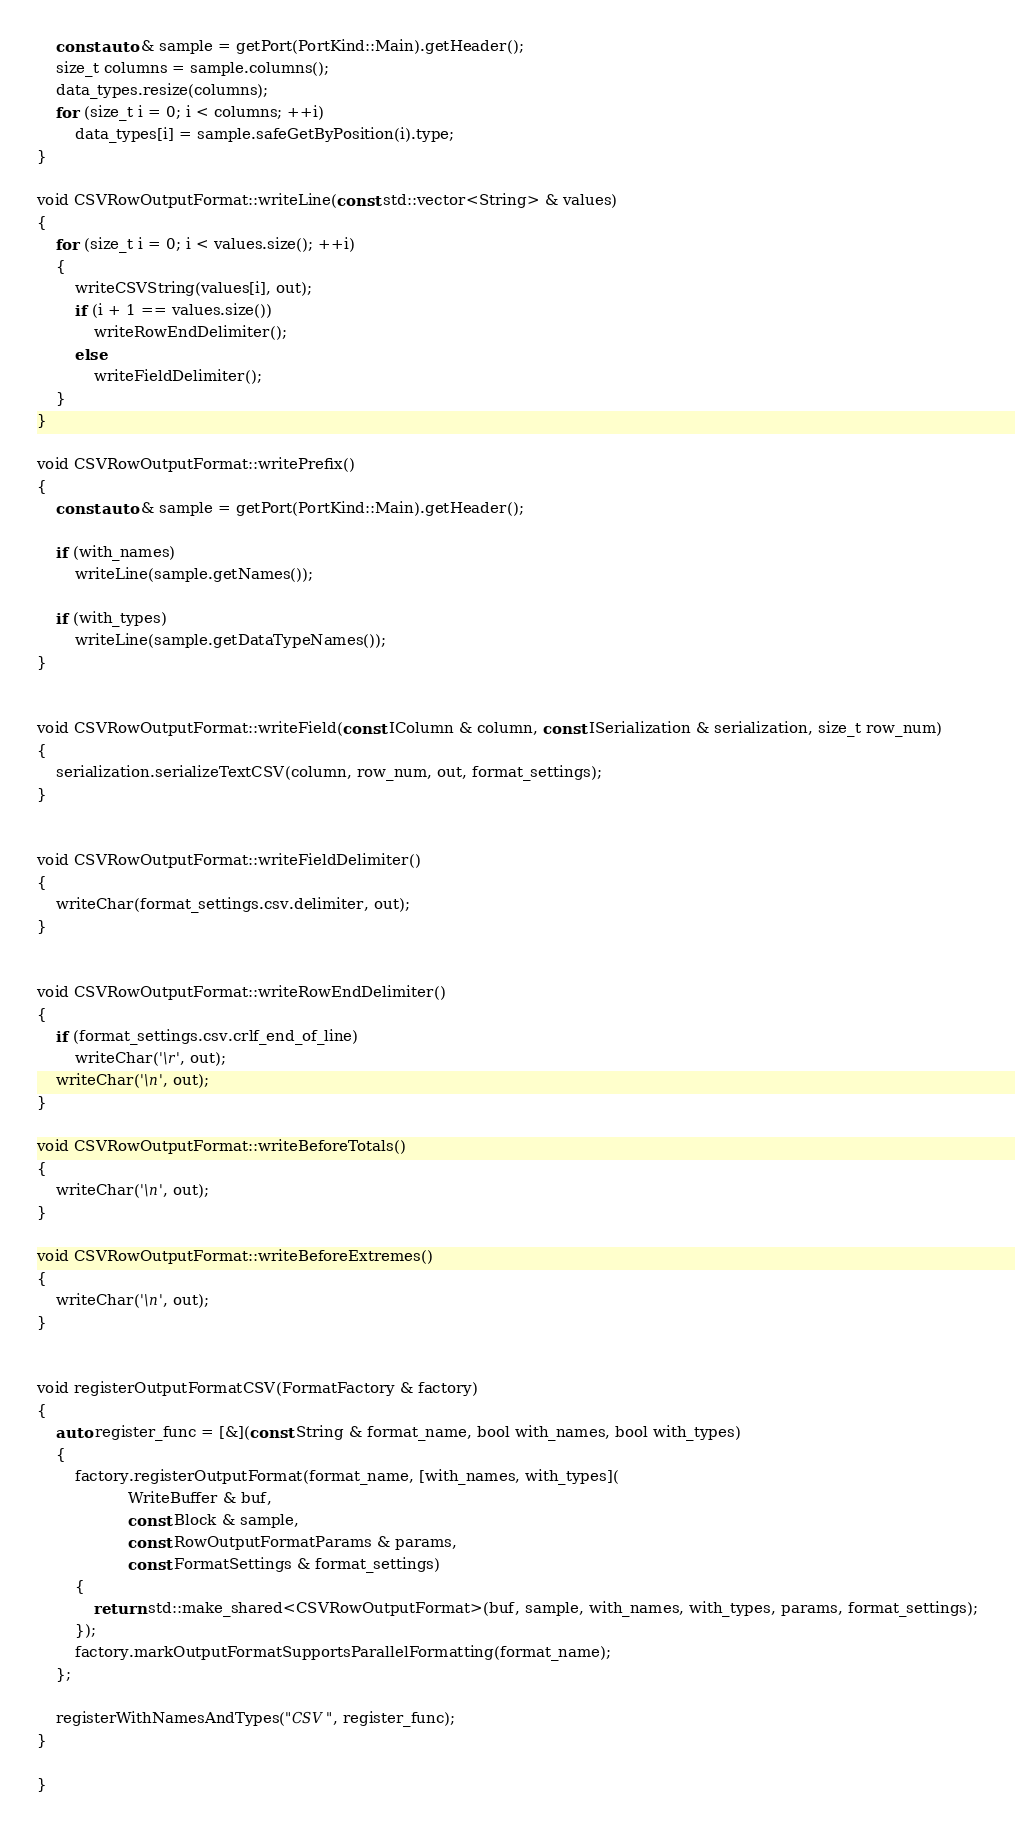Convert code to text. <code><loc_0><loc_0><loc_500><loc_500><_C++_>    const auto & sample = getPort(PortKind::Main).getHeader();
    size_t columns = sample.columns();
    data_types.resize(columns);
    for (size_t i = 0; i < columns; ++i)
        data_types[i] = sample.safeGetByPosition(i).type;
}

void CSVRowOutputFormat::writeLine(const std::vector<String> & values)
{
    for (size_t i = 0; i < values.size(); ++i)
    {
        writeCSVString(values[i], out);
        if (i + 1 == values.size())
            writeRowEndDelimiter();
        else
            writeFieldDelimiter();
    }
}

void CSVRowOutputFormat::writePrefix()
{
    const auto & sample = getPort(PortKind::Main).getHeader();

    if (with_names)
        writeLine(sample.getNames());

    if (with_types)
        writeLine(sample.getDataTypeNames());
}


void CSVRowOutputFormat::writeField(const IColumn & column, const ISerialization & serialization, size_t row_num)
{
    serialization.serializeTextCSV(column, row_num, out, format_settings);
}


void CSVRowOutputFormat::writeFieldDelimiter()
{
    writeChar(format_settings.csv.delimiter, out);
}


void CSVRowOutputFormat::writeRowEndDelimiter()
{
    if (format_settings.csv.crlf_end_of_line)
        writeChar('\r', out);
    writeChar('\n', out);
}

void CSVRowOutputFormat::writeBeforeTotals()
{
    writeChar('\n', out);
}

void CSVRowOutputFormat::writeBeforeExtremes()
{
    writeChar('\n', out);
}


void registerOutputFormatCSV(FormatFactory & factory)
{
    auto register_func = [&](const String & format_name, bool with_names, bool with_types)
    {
        factory.registerOutputFormat(format_name, [with_names, with_types](
                   WriteBuffer & buf,
                   const Block & sample,
                   const RowOutputFormatParams & params,
                   const FormatSettings & format_settings)
        {
            return std::make_shared<CSVRowOutputFormat>(buf, sample, with_names, with_types, params, format_settings);
        });
        factory.markOutputFormatSupportsParallelFormatting(format_name);
    };

    registerWithNamesAndTypes("CSV", register_func);
}

}
</code> 